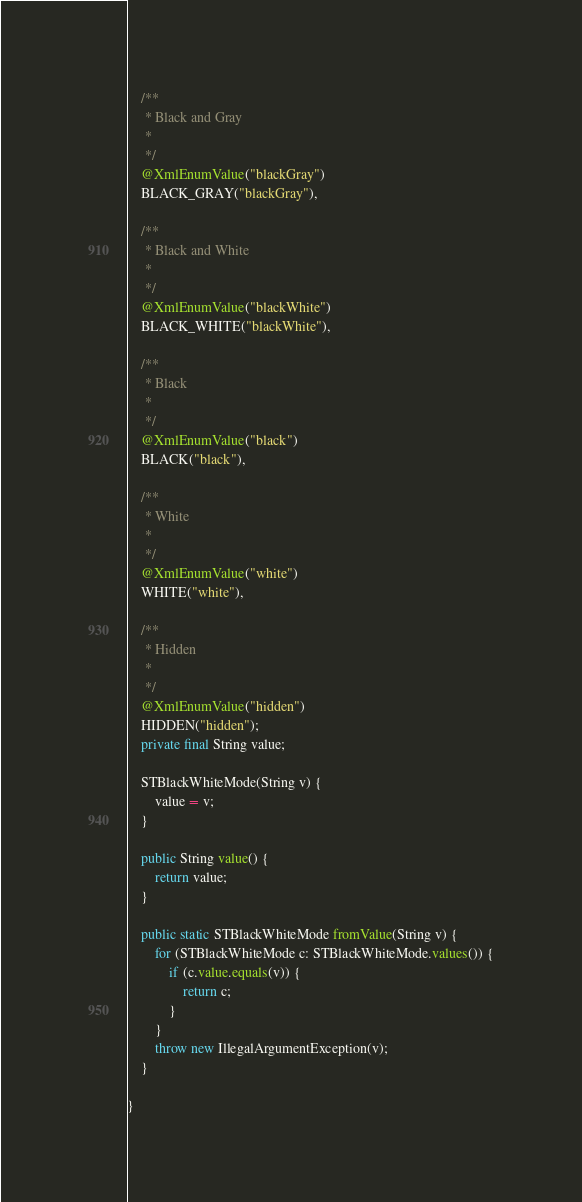Convert code to text. <code><loc_0><loc_0><loc_500><loc_500><_Java_>
    /**
     * Black and Gray
     * 
     */
    @XmlEnumValue("blackGray")
    BLACK_GRAY("blackGray"),

    /**
     * Black and White
     * 
     */
    @XmlEnumValue("blackWhite")
    BLACK_WHITE("blackWhite"),

    /**
     * Black
     * 
     */
    @XmlEnumValue("black")
    BLACK("black"),

    /**
     * White
     * 
     */
    @XmlEnumValue("white")
    WHITE("white"),

    /**
     * Hidden
     * 
     */
    @XmlEnumValue("hidden")
    HIDDEN("hidden");
    private final String value;

    STBlackWhiteMode(String v) {
        value = v;
    }

    public String value() {
        return value;
    }

    public static STBlackWhiteMode fromValue(String v) {
        for (STBlackWhiteMode c: STBlackWhiteMode.values()) {
            if (c.value.equals(v)) {
                return c;
            }
        }
        throw new IllegalArgumentException(v);
    }

}
</code> 